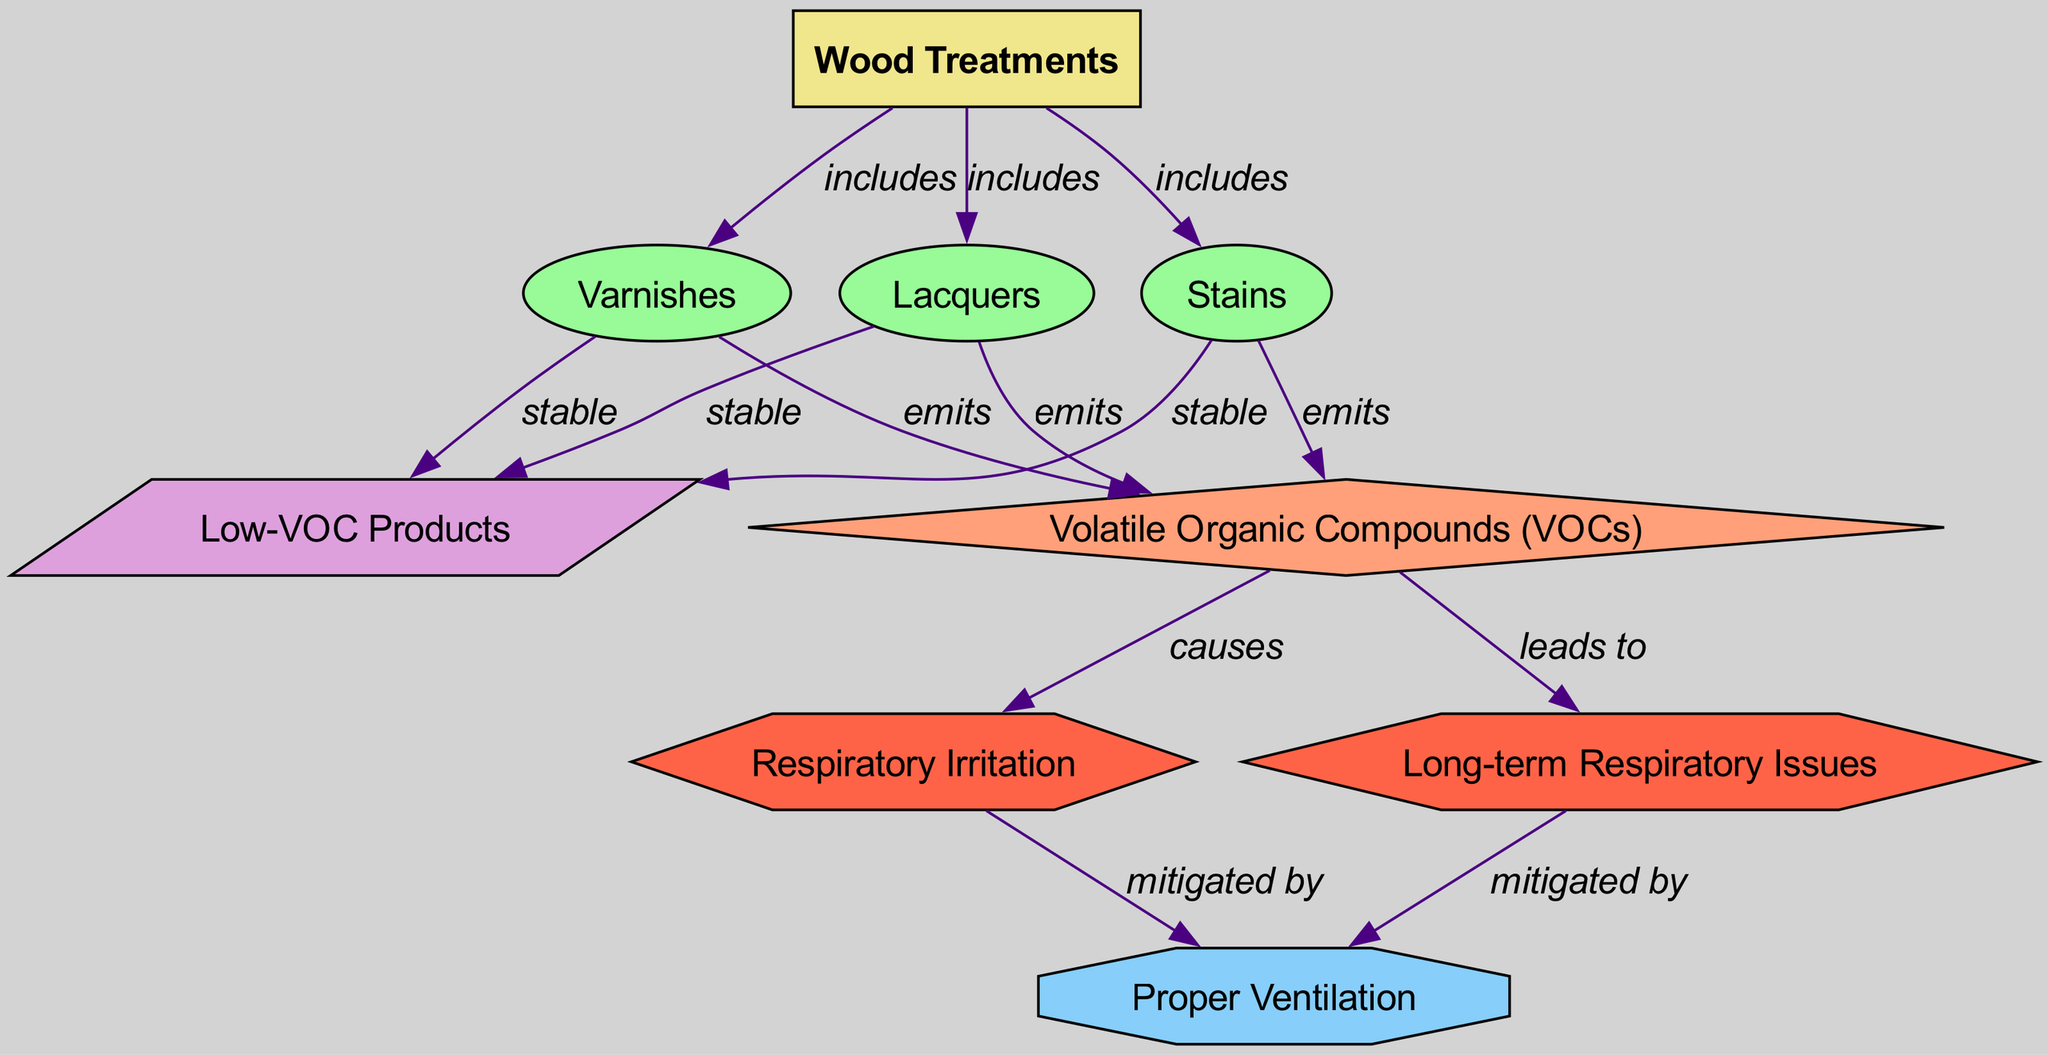What types of wood treatments are mentioned? The diagram includes three types of wood treatments: Varnishes, Stains, and Lacquers. These treatments are categorized under the main node labeled "Wood Treatments."
Answer: Varnishes, Stains, Lacquers How many health effects are listed in the diagram? The diagram shows three health effects: Respiratory Irritation, Long-term Respiratory Issues, and the prevention methods associated with these effects. By counting the unique health effect nodes, we can determine the total amount.
Answer: 2 Which wood treatment type has stable alternatives? Each of the wood treatment types (Varnishes, Stains, and Lacquers) is linked to the node "Low-VOC Products," which indicates that all of them have stable alternatives.
Answer: Low-VOC Products What do volatile organic compounds cause? The edge labeled "causes" connects the node "Volatile Organic Compounds (VOCs)" to the health effect node "Respiratory Irritation," indicating that the presence of VOCs results in respiratory discomfort.
Answer: Respiratory Irritation What is a prevention method for respiratory issues? The diagram indicates that both Respiratory Irritation and Long-term Respiratory Issues can be mitigated by "Proper Ventilation." This means providing proper airflow helps reduce the health impact.
Answer: Proper Ventilation What do all wood treatments emit? According to the diagram, all types of wood treatments, including Varnishes, Stains, and Lacquers, emit Volatile Organic Compounds (VOCs), as shown by the directed edges leading from each treatment to the VOCs node.
Answer: Volatile Organic Compounds (VOCs) How many edges are present in the diagram? By counting all the connections (edges) that link the nodes, we find that there is a total of 12 edges that represent the relationships among wood treatments, effects, health effects, prevention, and alternatives.
Answer: 12 What health issue is most directly caused by VOCs? The diagram directly connects Volatile Organic Compounds (VOCs) to Respiratory Irritation as one of the primary health issues they cause, as reflected by the directed edge "causes."
Answer: Respiratory Irritation 